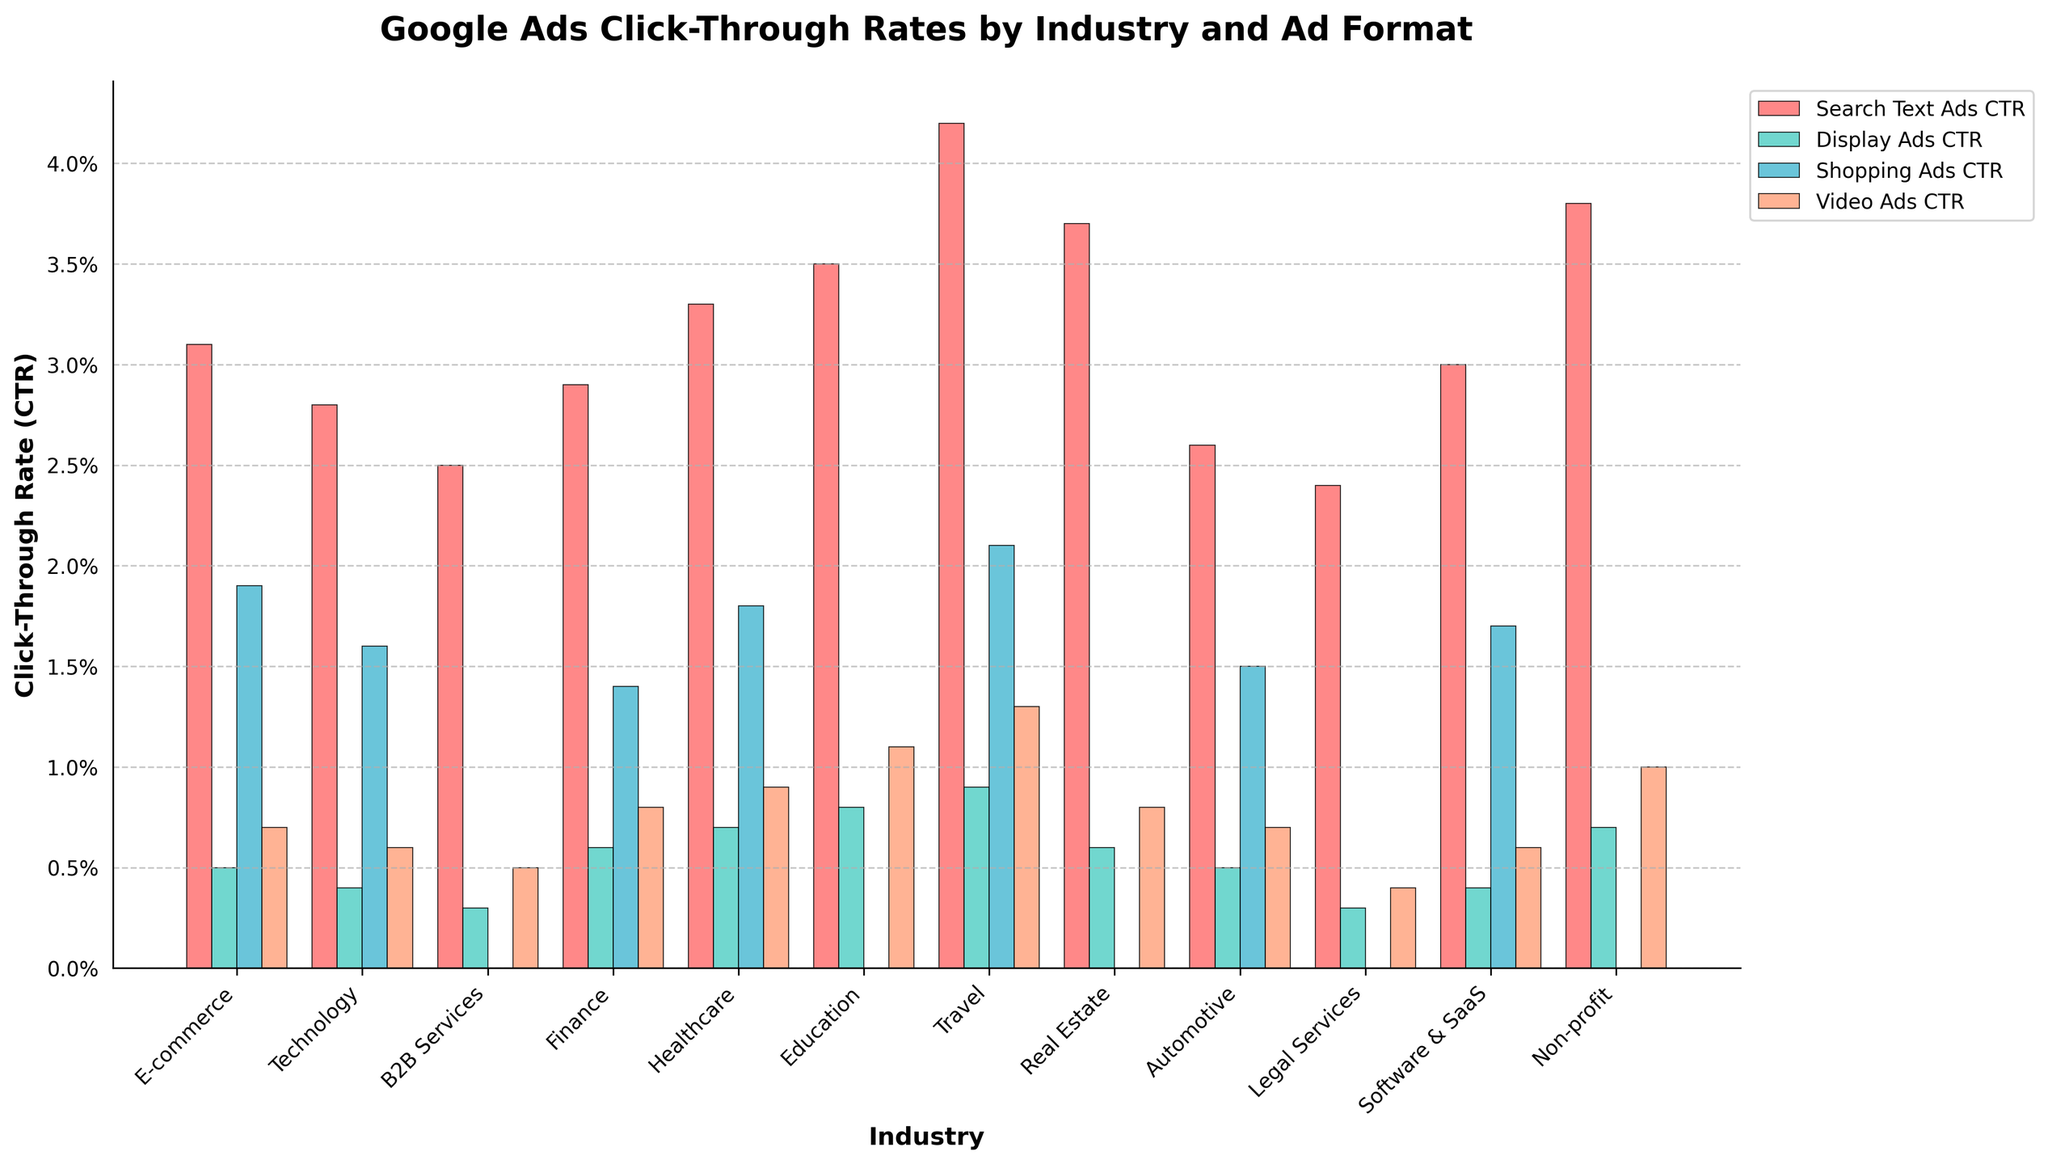Which industry has the highest Search Text Ads CTR? The industry with the highest bar in the 'Search Text Ads CTR' group is the Travel industry.
Answer: Travel Which industry has the lowest Video Ads CTR? The shortest bar in the 'Video Ads CTR' group belongs to the Legal Services industry.
Answer: Legal Services How much greater is the Display Ads CTR of Travel compared to Technology? The Display Ads CTR for Travel is 0.9%, and for Technology, it is 0.4%. So the difference is 0.5%
Answer: 0.5% What is the average Shopping Ads CTR across E-commerce, Technology, and Finance industries? Sum the Shopping Ads CTRs for E-commerce, Technology, and Finance: 1.9% + 1.6% + 1.4% = 4.9%, and divide by 3: 4.9 / 3 = 1.63%
Answer: 1.63% Compare the height of the Shopping Ads CTR bar to the Display Ads CTR bar for Healthcare. Which is taller? The Shopping Ads CTR for Healthcare is 1.8%, while the Display Ads CTR for Healthcare is 0.7%, making the Shopping Ads CTR bar taller.
Answer: Shopping Ads CTR Which ad format has the most consistent CTR across all industries? By visually inspecting the bars, 'Display Ads CTR' bars appear to have the least variation across industries.
Answer: Display Ads CTR By how much does the Video Ads CTR for Education surpass the Shopping Ads CTR for Automotive? The Video Ads CTR for Education is 1.1%, and the Shopping Ads CTR for Automotive is 1.5%. The difference is 1.1% - 1.5% = -0.4%, so it does not surpass; instead, it is lower by 0.4%.
Answer: Does not surpass How many industries have a Display Ads CTR of at least 0.7%? The industries with a Display Ads CTR of at least 0.7% are Healthcare, Education, Travel, Real Estate, and Non-profit—5 industries in total.
Answer: 5 Does any industry have a Shopping Ads CTR exceeding its Search Text Ads CTR? By examining the Shopping Ads CTR and Search Text Ads CTR bars, no industry has a Shopping Ads CTR exceeding its Search Text Ads CTR.
Answer: No 